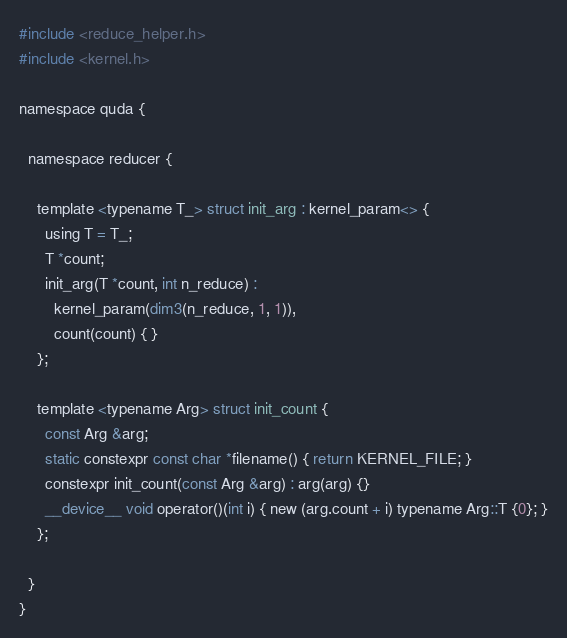<code> <loc_0><loc_0><loc_500><loc_500><_Cuda_>#include <reduce_helper.h>
#include <kernel.h>

namespace quda {

  namespace reducer {

    template <typename T_> struct init_arg : kernel_param<> {
      using T = T_;
      T *count;
      init_arg(T *count, int n_reduce) :
        kernel_param(dim3(n_reduce, 1, 1)),
        count(count) { }
    };

    template <typename Arg> struct init_count {
      const Arg &arg;
      static constexpr const char *filename() { return KERNEL_FILE; }
      constexpr init_count(const Arg &arg) : arg(arg) {}
      __device__ void operator()(int i) { new (arg.count + i) typename Arg::T {0}; }
    };

  }
}
</code> 